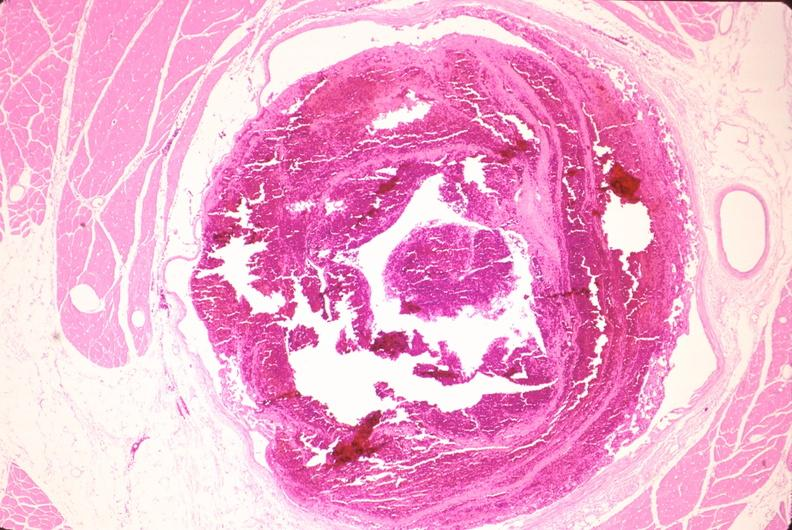where is this from?
Answer the question using a single word or phrase. Vasculature 